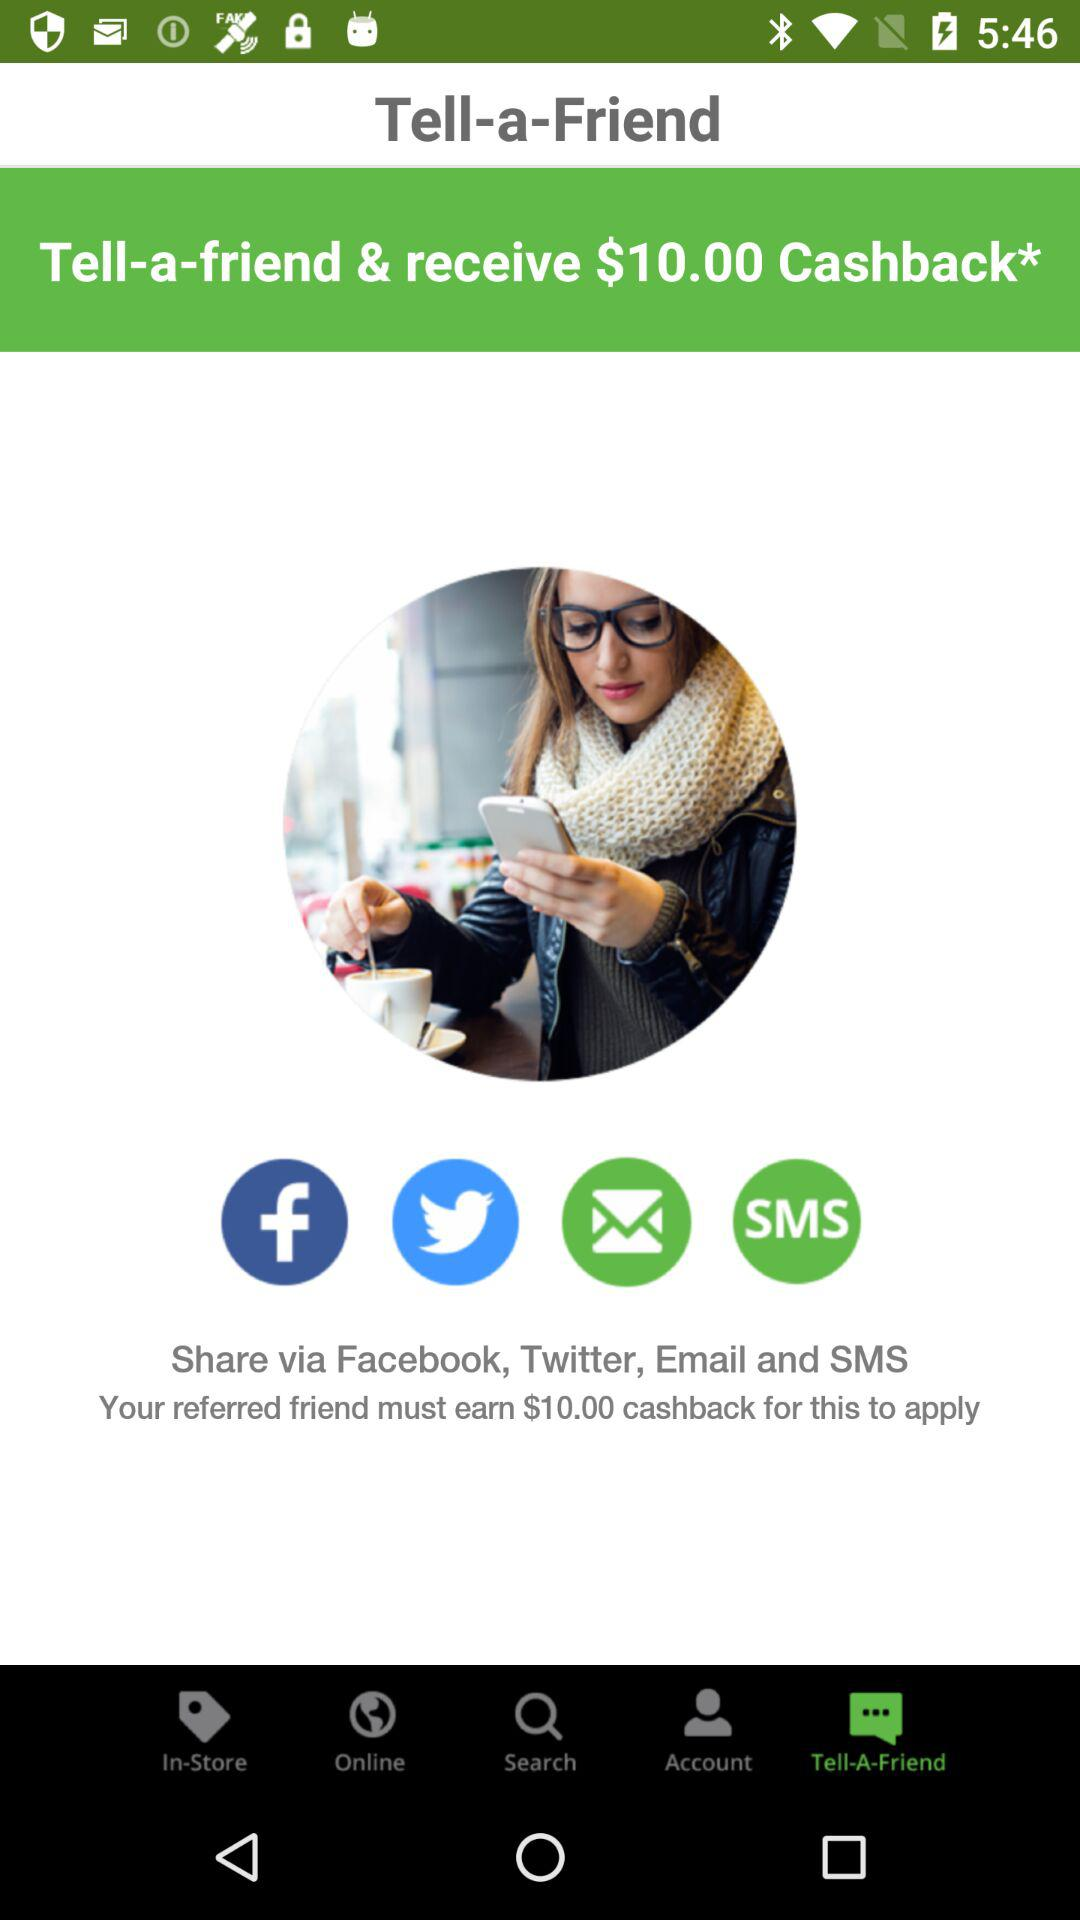Which account is currently in use?
When the provided information is insufficient, respond with <no answer>. <no answer> 